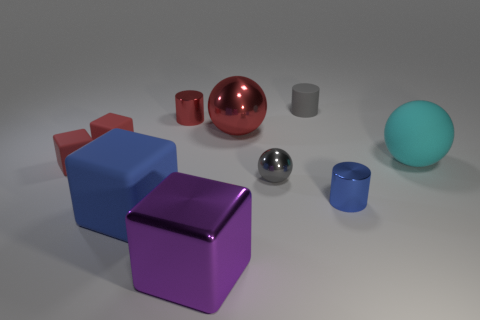What is the material of the purple block?
Make the answer very short. Metal. There is a sphere on the right side of the blue metal object; does it have the same size as the big red metal thing?
Your answer should be very brief. Yes. How many things are either red metallic spheres or green shiny balls?
Your response must be concise. 1. There is a thing that is the same color as the small rubber cylinder; what is its shape?
Your response must be concise. Sphere. There is a matte object that is both behind the large cyan object and left of the small gray metallic ball; what is its size?
Your answer should be very brief. Small. How many red metallic cylinders are there?
Your answer should be very brief. 1. What number of spheres are either small rubber objects or large red shiny things?
Ensure brevity in your answer.  1. What number of big blocks are behind the block that is to the right of the small cylinder that is to the left of the big purple object?
Offer a very short reply. 1. There is another shiny cylinder that is the same size as the red cylinder; what color is it?
Provide a succinct answer. Blue. What number of other objects are there of the same color as the tiny metallic sphere?
Offer a very short reply. 1. 